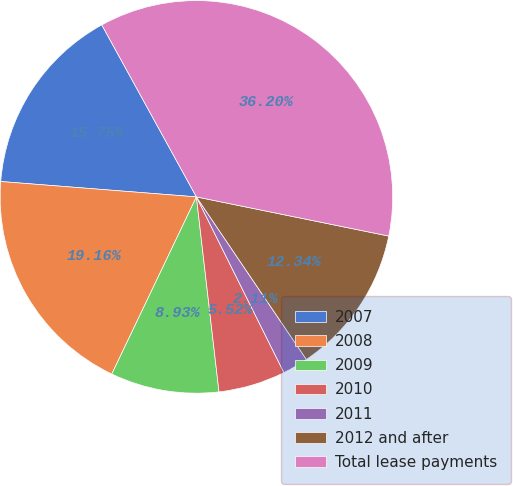Convert chart to OTSL. <chart><loc_0><loc_0><loc_500><loc_500><pie_chart><fcel>2007<fcel>2008<fcel>2009<fcel>2010<fcel>2011<fcel>2012 and after<fcel>Total lease payments<nl><fcel>15.75%<fcel>19.16%<fcel>8.93%<fcel>5.52%<fcel>2.11%<fcel>12.34%<fcel>36.21%<nl></chart> 